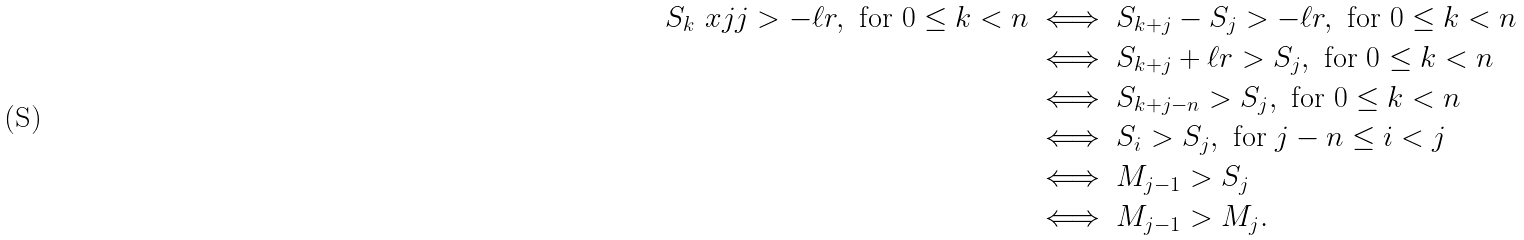Convert formula to latex. <formula><loc_0><loc_0><loc_500><loc_500>S _ { k } \ x j j > - \ell r , \text { for $0\leq k<n$} & \iff S _ { k + j } - S _ { j } > - \ell r , \text { for $0\leq k<n$} \\ & \iff S _ { k + j } + \ell r > S _ { j } , \text { for $0\leq k<n$} \\ & \iff S _ { k + j - n } > S _ { j } , \text { for $0\leq k<n$} \\ & \iff S _ { i } > S _ { j } , \text { for $j-n\leq i<j$} \\ & \iff M _ { j - 1 } > S _ { j } \\ & \iff M _ { j - 1 } > M _ { j } .</formula> 